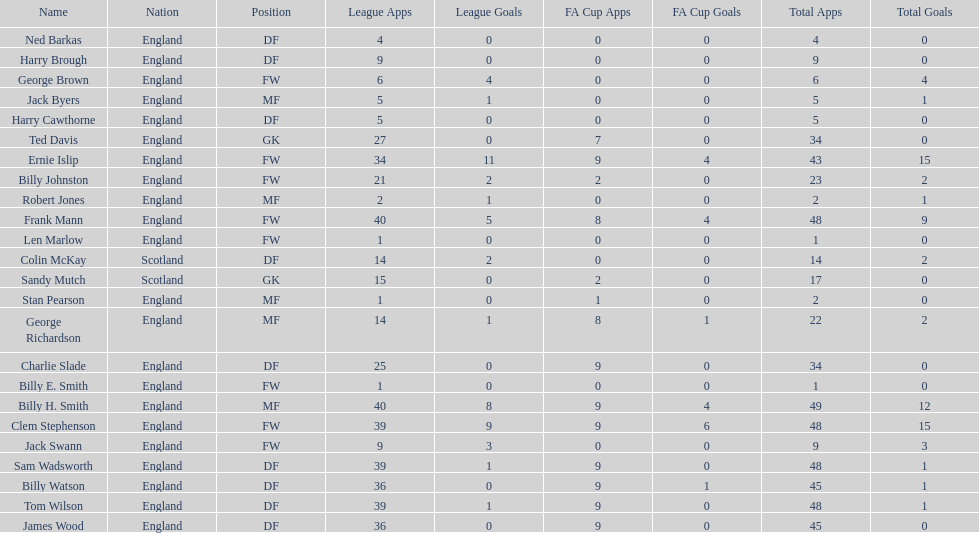What is the primary name noted down? Ned Barkas. 